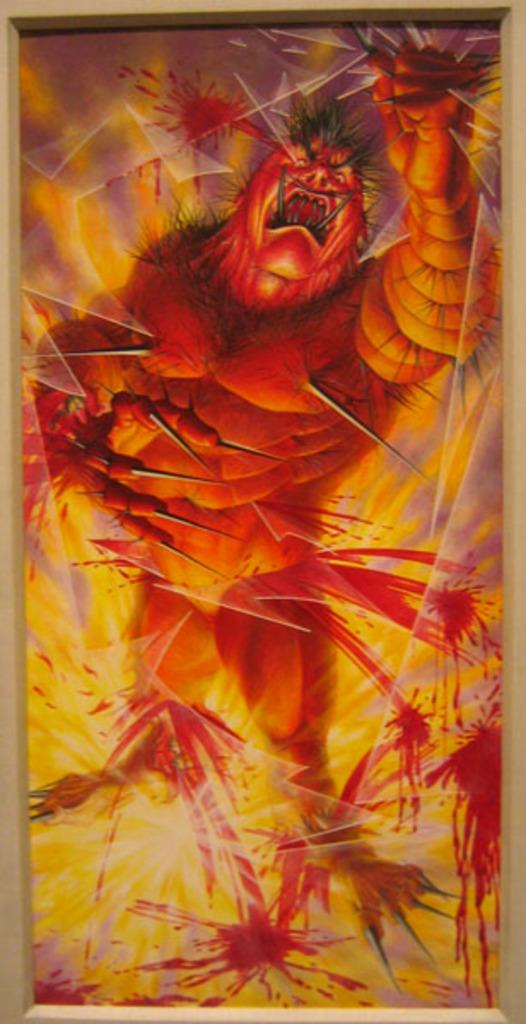What is depicted in the painting in the image? There is a painting of a beast in the image. What color is the beast in the painting? The beast in the painting is orange in color. What else can be seen in the image besides the painting? There is a fire visible in the image. What color is the fire in the image? The fire is yellow in color. What time is indicated by the caption on the painting in the image? There is no caption present on the painting in the image, so it is not possible to determine the time. 